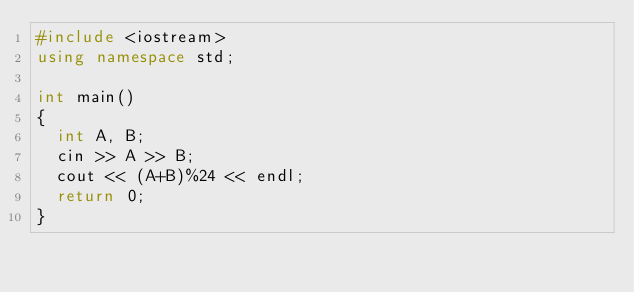<code> <loc_0><loc_0><loc_500><loc_500><_C++_>#include <iostream>
using namespace std;

int main()
{
  int A, B;
  cin >> A >> B;
  cout << (A+B)%24 << endl;
  return 0;
}</code> 